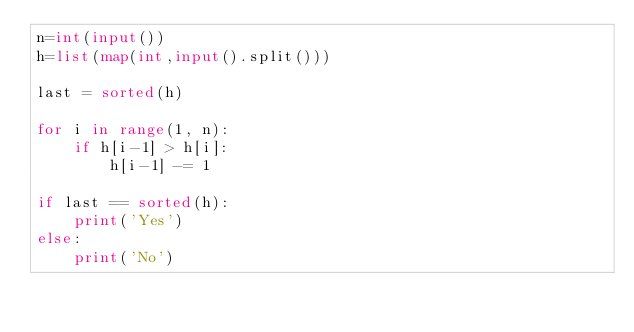Convert code to text. <code><loc_0><loc_0><loc_500><loc_500><_Python_>n=int(input())
h=list(map(int,input().split()))

last = sorted(h)

for i in range(1, n):
    if h[i-1] > h[i]:
        h[i-1] -= 1

if last == sorted(h):
    print('Yes')     
else:
    print('No')</code> 